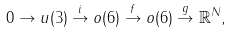Convert formula to latex. <formula><loc_0><loc_0><loc_500><loc_500>0 \to u ( 3 ) \overset { i } { \to } o ( 6 ) \overset { f } { \to } o ( 6 ) \overset { g } { \to } \mathbb { R } ^ { N } ,</formula> 